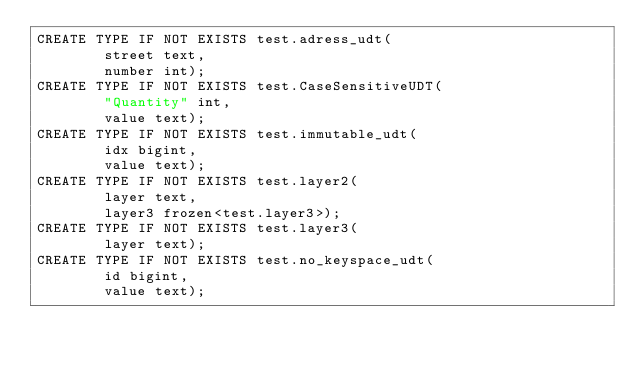Convert code to text. <code><loc_0><loc_0><loc_500><loc_500><_SQL_>CREATE TYPE IF NOT EXISTS test.adress_udt(
		street text,
		number int);
CREATE TYPE IF NOT EXISTS test.CaseSensitiveUDT(
		"Quantity" int,
		value text);
CREATE TYPE IF NOT EXISTS test.immutable_udt(
		idx bigint,
		value text);
CREATE TYPE IF NOT EXISTS test.layer2(
		layer text,
		layer3 frozen<test.layer3>);
CREATE TYPE IF NOT EXISTS test.layer3(
		layer text);
CREATE TYPE IF NOT EXISTS test.no_keyspace_udt(
		id bigint,
		value text);</code> 